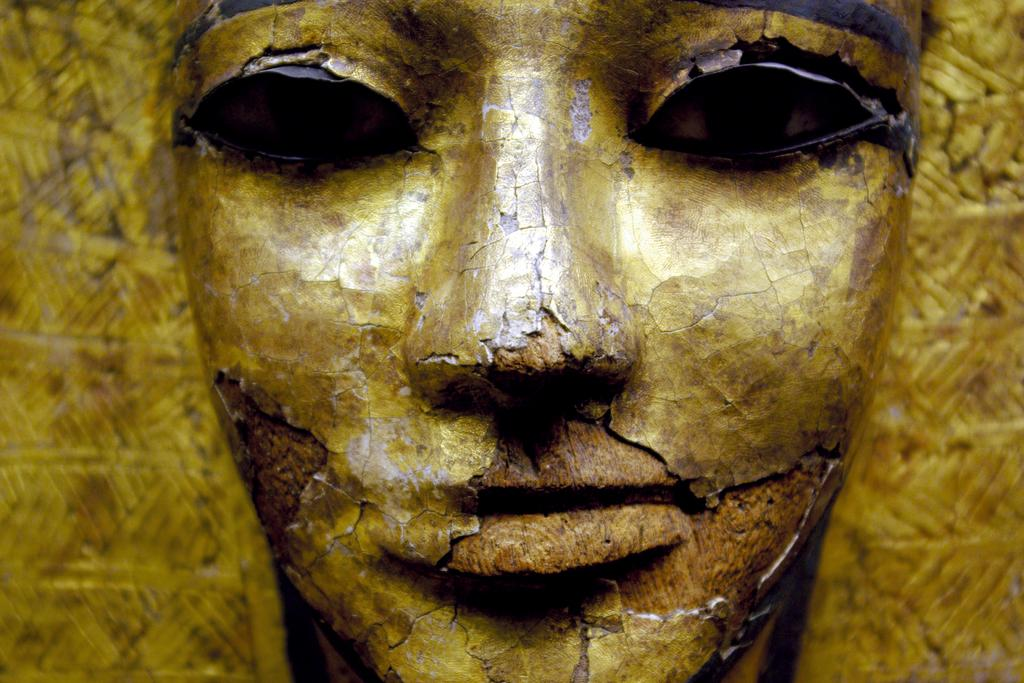What is the main subject of the image? There is a sculpture in the image. What type of advice can be heard coming from the sculpture in the image? There is no indication in the image that the sculpture is providing advice, as sculptures are inanimate objects and cannot speak or give advice. 